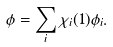<formula> <loc_0><loc_0><loc_500><loc_500>\phi = \sum _ { i } \chi _ { i } ( 1 ) \phi _ { i } .</formula> 